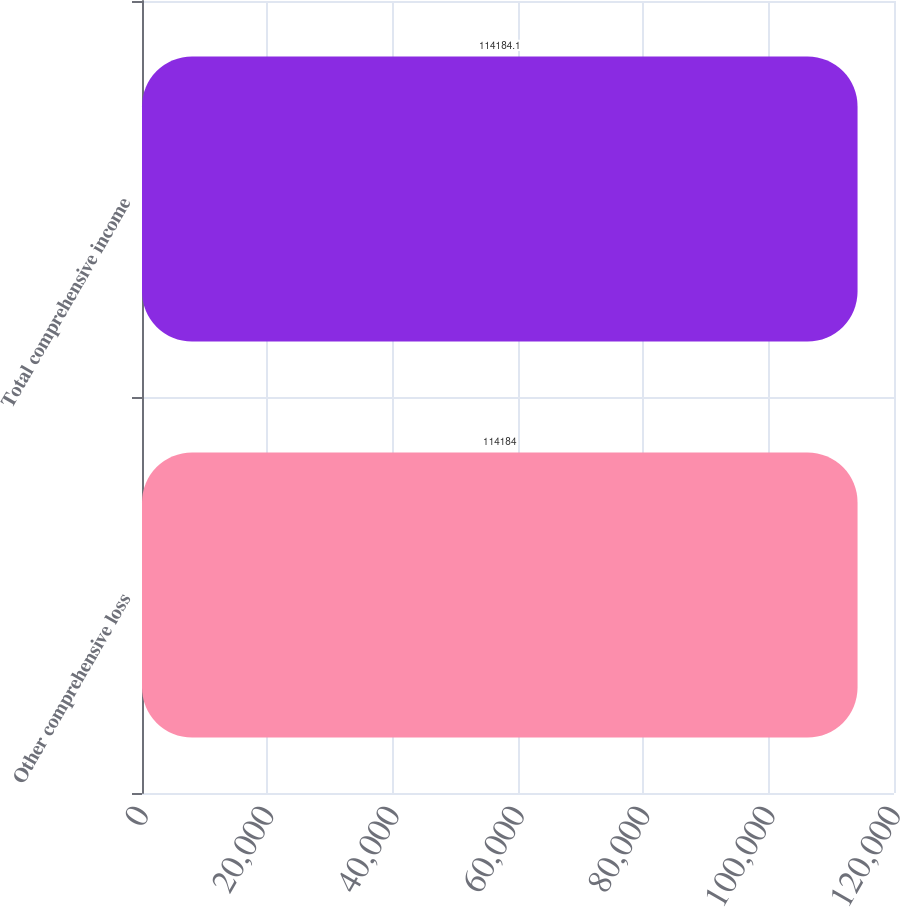Convert chart to OTSL. <chart><loc_0><loc_0><loc_500><loc_500><bar_chart><fcel>Other comprehensive loss<fcel>Total comprehensive income<nl><fcel>114184<fcel>114184<nl></chart> 